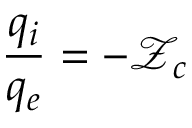<formula> <loc_0><loc_0><loc_500><loc_500>\frac { q _ { i } } { q _ { e } } = - \mathcal { Z } _ { c }</formula> 